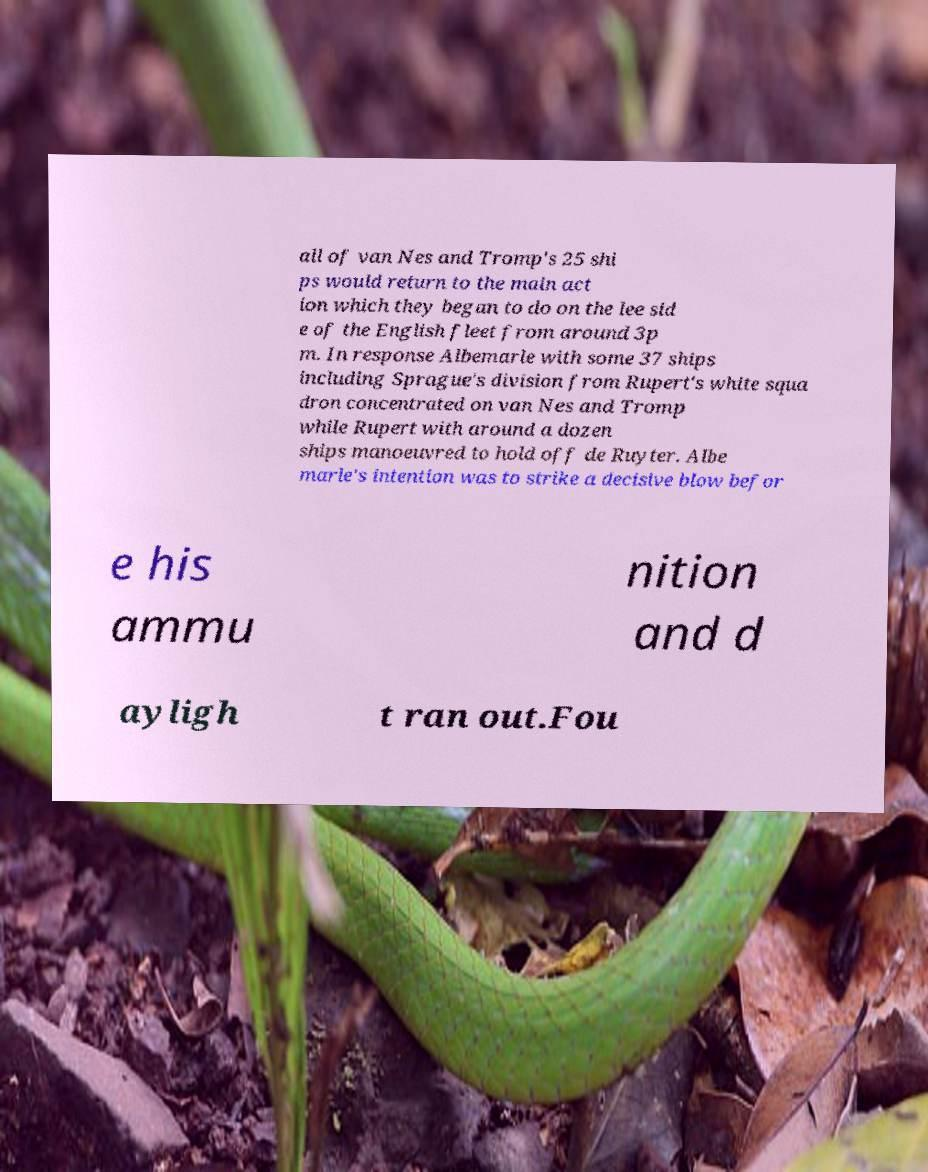For documentation purposes, I need the text within this image transcribed. Could you provide that? all of van Nes and Tromp's 25 shi ps would return to the main act ion which they began to do on the lee sid e of the English fleet from around 3p m. In response Albemarle with some 37 ships including Sprague's division from Rupert's white squa dron concentrated on van Nes and Tromp while Rupert with around a dozen ships manoeuvred to hold off de Ruyter. Albe marle's intention was to strike a decisive blow befor e his ammu nition and d ayligh t ran out.Fou 